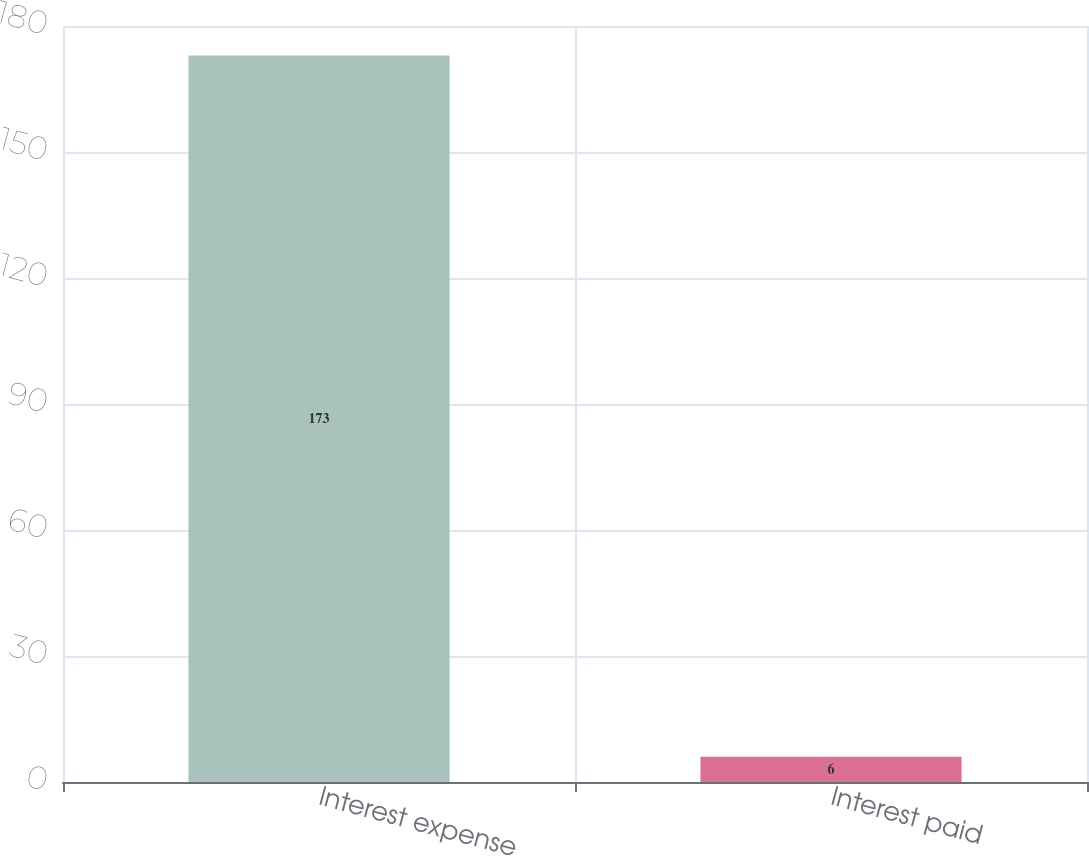<chart> <loc_0><loc_0><loc_500><loc_500><bar_chart><fcel>Interest expense<fcel>Interest paid<nl><fcel>173<fcel>6<nl></chart> 